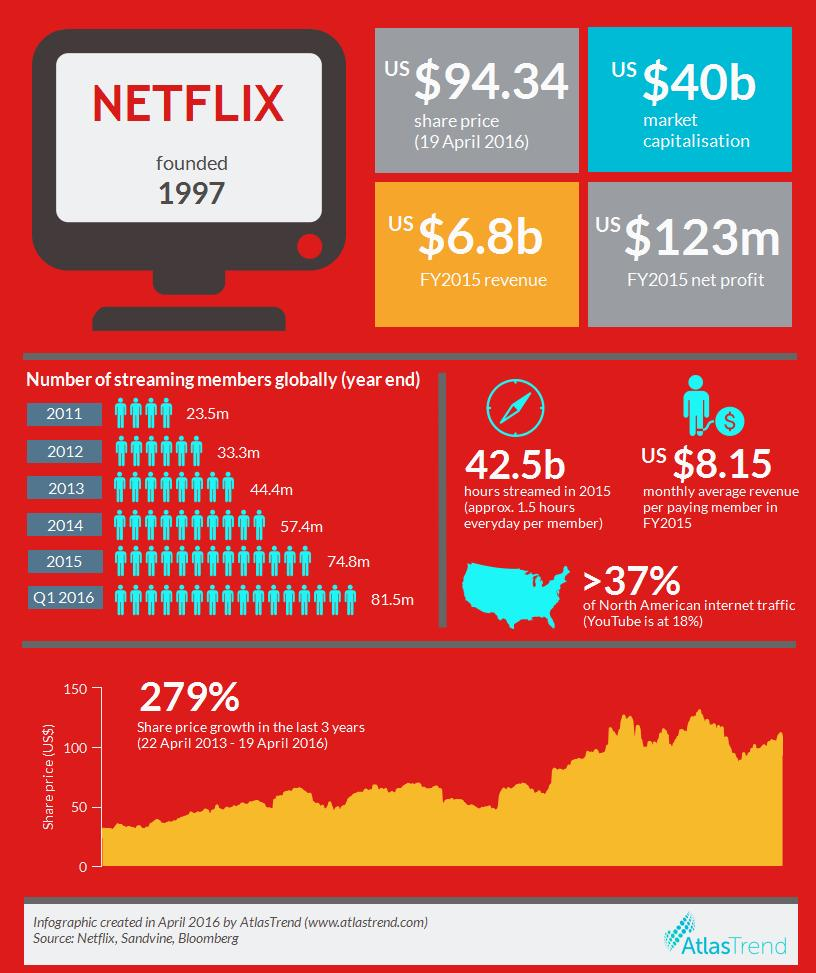Outline some significant characteristics in this image. In the year-end of 2014, the number of streaming members of Netflix globally was 57.4 million. Netflix's net profit in the fiscal year 2015 was $123 million in US dollars. In the fiscal year 2015, Netflix's revenue was approximately 6.8 billion US dollars. In the fiscal year 2015, Netflix's monthly average revenue per paying member was approximately $8.15 in the United States. As of April 19th, 2016, the share price of Netflix in US dollars was 94.34. 